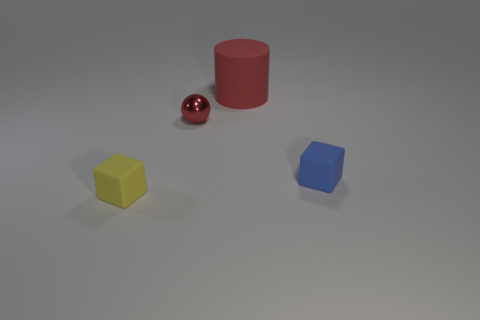Subtract 1 cubes. How many cubes are left? 1 Subtract all yellow cubes. How many cubes are left? 1 Subtract all cylinders. How many objects are left? 3 Add 3 big red balls. How many objects exist? 7 Subtract all yellow blocks. How many gray balls are left? 0 Subtract all spheres. Subtract all cylinders. How many objects are left? 2 Add 1 tiny things. How many tiny things are left? 4 Add 1 small metallic balls. How many small metallic balls exist? 2 Subtract 0 gray spheres. How many objects are left? 4 Subtract all green balls. Subtract all blue cylinders. How many balls are left? 1 